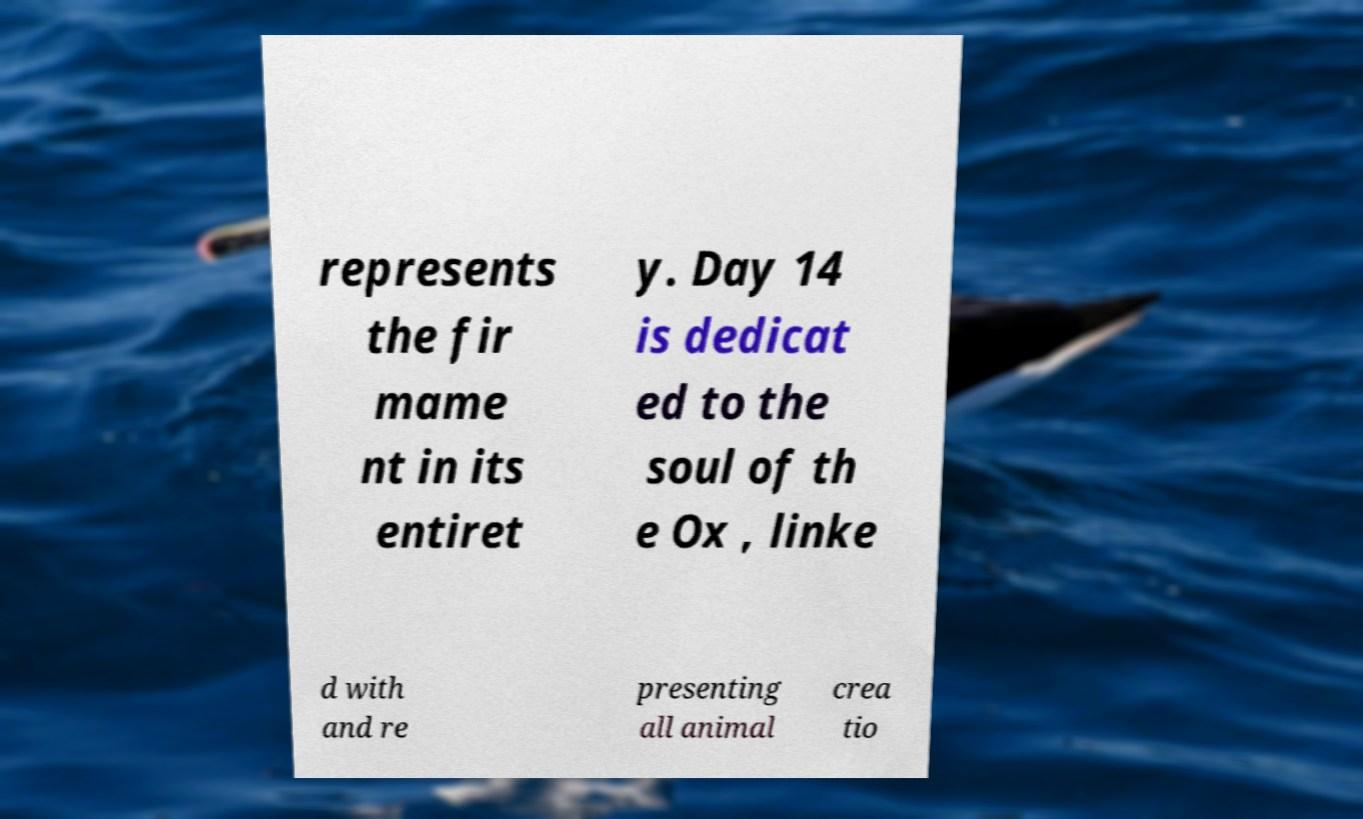Please read and relay the text visible in this image. What does it say? represents the fir mame nt in its entiret y. Day 14 is dedicat ed to the soul of th e Ox , linke d with and re presenting all animal crea tio 